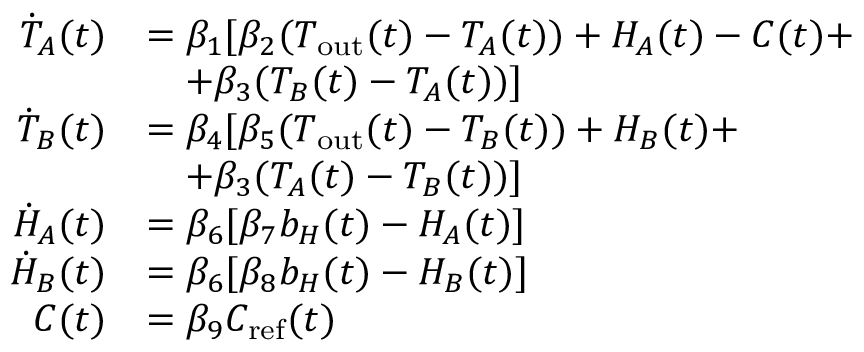<formula> <loc_0><loc_0><loc_500><loc_500>\begin{array} { r l } { \dot { T } _ { A } ( t ) } & { = \beta _ { 1 } [ \beta _ { 2 } ( T _ { o u t } ( t ) - T _ { A } ( t ) ) + H _ { A } ( t ) - C ( t ) + } \\ & { \quad + \beta _ { 3 } ( T _ { B } ( t ) - T _ { A } ( t ) ) ] } \\ { \dot { T } _ { B } ( t ) } & { = \beta _ { 4 } [ \beta _ { 5 } ( T _ { o u t } ( t ) - T _ { B } ( t ) ) + H _ { B } ( t ) + } \\ & { \quad + \beta _ { 3 } ( T _ { A } ( t ) - T _ { B } ( t ) ) ] } \\ { \dot { H } _ { A } ( t ) } & { = \beta _ { 6 } [ \beta _ { 7 } b _ { H } ( t ) - H _ { A } ( t ) ] } \\ { \dot { H } _ { B } ( t ) } & { = \beta _ { 6 } [ \beta _ { 8 } b _ { H } ( t ) - H _ { B } ( t ) ] } \\ { C ( t ) } & { = \beta _ { 9 } C _ { r e f } ( t ) } \end{array}</formula> 